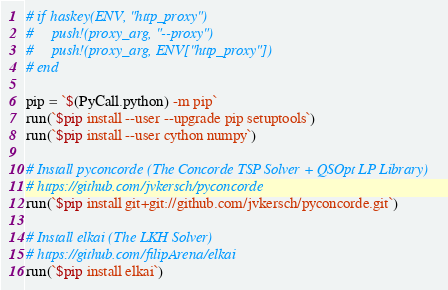Convert code to text. <code><loc_0><loc_0><loc_500><loc_500><_Julia_># if haskey(ENV, "http_proxy")
#     push!(proxy_arg, "--proxy")
#     push!(proxy_arg, ENV["http_proxy"])
# end

pip = `$(PyCall.python) -m pip`
run(`$pip install --user --upgrade pip setuptools`)
run(`$pip install --user cython numpy`)

# Install pyconcorde (The Concorde TSP Solver + QSOpt LP Library)
# https://github.com/jvkersch/pyconcorde
run(`$pip install git+git://github.com/jvkersch/pyconcorde.git`)

# Install elkai (The LKH Solver)
# https://github.com/filipArena/elkai
run(`$pip install elkai`)
</code> 